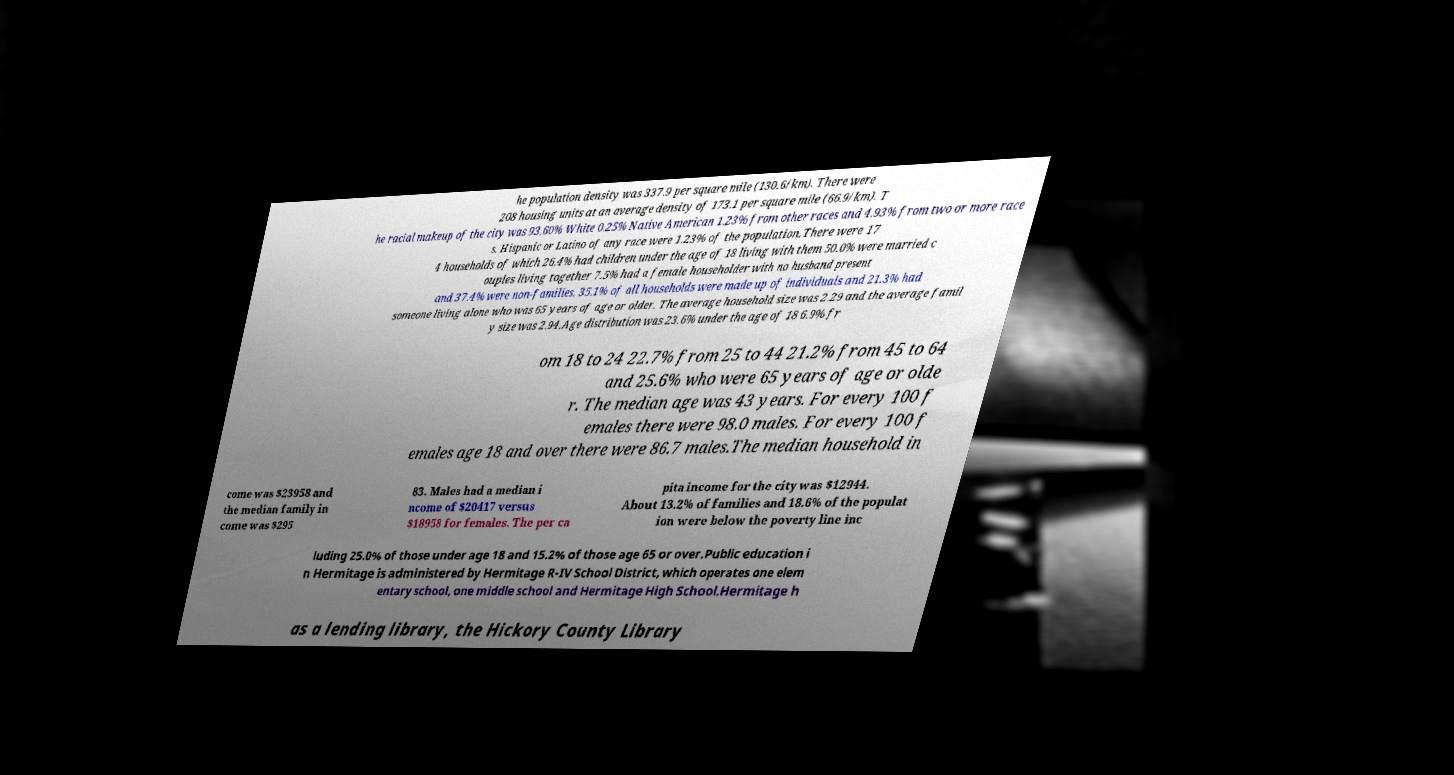Could you assist in decoding the text presented in this image and type it out clearly? he population density was 337.9 per square mile (130.6/km). There were 208 housing units at an average density of 173.1 per square mile (66.9/km). T he racial makeup of the city was 93.60% White 0.25% Native American 1.23% from other races and 4.93% from two or more race s. Hispanic or Latino of any race were 1.23% of the population.There were 17 4 households of which 26.4% had children under the age of 18 living with them 50.0% were married c ouples living together 7.5% had a female householder with no husband present and 37.4% were non-families. 35.1% of all households were made up of individuals and 21.3% had someone living alone who was 65 years of age or older. The average household size was 2.29 and the average famil y size was 2.94.Age distribution was 23.6% under the age of 18 6.9% fr om 18 to 24 22.7% from 25 to 44 21.2% from 45 to 64 and 25.6% who were 65 years of age or olde r. The median age was 43 years. For every 100 f emales there were 98.0 males. For every 100 f emales age 18 and over there were 86.7 males.The median household in come was $23958 and the median family in come was $295 83. Males had a median i ncome of $20417 versus $18958 for females. The per ca pita income for the city was $12944. About 13.2% of families and 18.6% of the populat ion were below the poverty line inc luding 25.0% of those under age 18 and 15.2% of those age 65 or over.Public education i n Hermitage is administered by Hermitage R-IV School District, which operates one elem entary school, one middle school and Hermitage High School.Hermitage h as a lending library, the Hickory County Library 